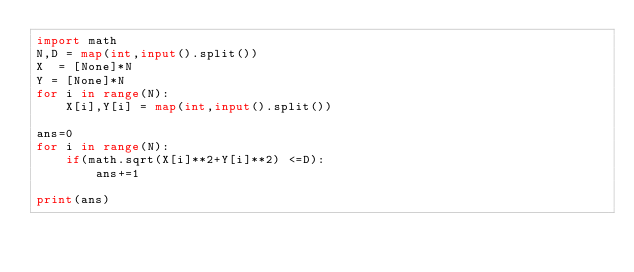Convert code to text. <code><loc_0><loc_0><loc_500><loc_500><_Python_>import math
N,D = map(int,input().split())
X  = [None]*N
Y = [None]*N
for i in range(N):
    X[i],Y[i] = map(int,input().split())

ans=0
for i in range(N):
    if(math.sqrt(X[i]**2+Y[i]**2) <=D):
        ans+=1

print(ans)
</code> 